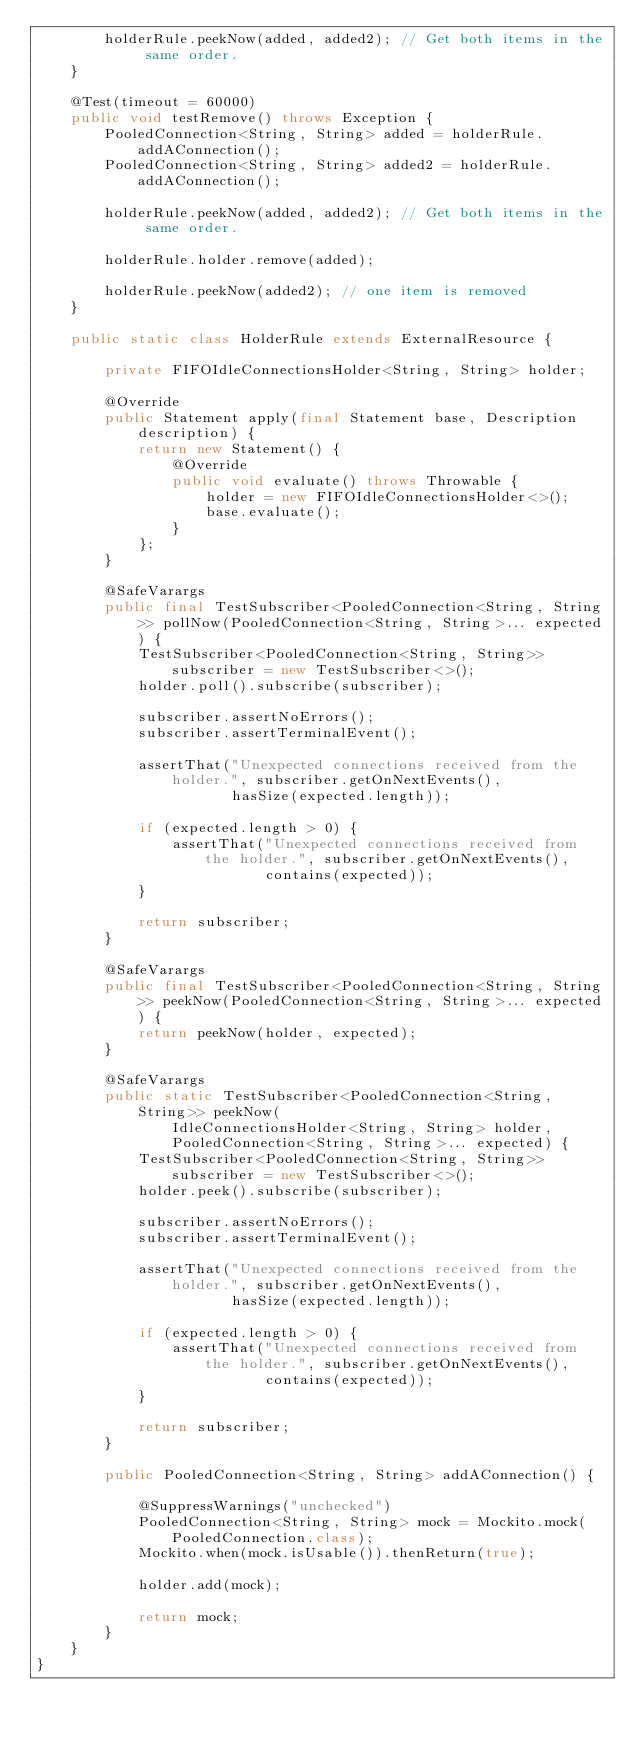<code> <loc_0><loc_0><loc_500><loc_500><_Java_>        holderRule.peekNow(added, added2); // Get both items in the same order.
    }

    @Test(timeout = 60000)
    public void testRemove() throws Exception {
        PooledConnection<String, String> added = holderRule.addAConnection();
        PooledConnection<String, String> added2 = holderRule.addAConnection();

        holderRule.peekNow(added, added2); // Get both items in the same order.

        holderRule.holder.remove(added);

        holderRule.peekNow(added2); // one item is removed
    }

    public static class HolderRule extends ExternalResource {

        private FIFOIdleConnectionsHolder<String, String> holder;

        @Override
        public Statement apply(final Statement base, Description description) {
            return new Statement() {
                @Override
                public void evaluate() throws Throwable {
                    holder = new FIFOIdleConnectionsHolder<>();
                    base.evaluate();
                }
            };
        }

        @SafeVarargs
        public final TestSubscriber<PooledConnection<String, String>> pollNow(PooledConnection<String, String>... expected) {
            TestSubscriber<PooledConnection<String, String>> subscriber = new TestSubscriber<>();
            holder.poll().subscribe(subscriber);

            subscriber.assertNoErrors();
            subscriber.assertTerminalEvent();

            assertThat("Unexpected connections received from the holder.", subscriber.getOnNextEvents(),
                       hasSize(expected.length));

            if (expected.length > 0) {
                assertThat("Unexpected connections received from the holder.", subscriber.getOnNextEvents(),
                           contains(expected));
            }

            return subscriber;
        }

        @SafeVarargs
        public final TestSubscriber<PooledConnection<String, String>> peekNow(PooledConnection<String, String>... expected) {
            return peekNow(holder, expected);
        }

        @SafeVarargs
        public static TestSubscriber<PooledConnection<String, String>> peekNow(
                IdleConnectionsHolder<String, String> holder,
                PooledConnection<String, String>... expected) {
            TestSubscriber<PooledConnection<String, String>> subscriber = new TestSubscriber<>();
            holder.peek().subscribe(subscriber);

            subscriber.assertNoErrors();
            subscriber.assertTerminalEvent();

            assertThat("Unexpected connections received from the holder.", subscriber.getOnNextEvents(),
                       hasSize(expected.length));

            if (expected.length > 0) {
                assertThat("Unexpected connections received from the holder.", subscriber.getOnNextEvents(),
                           contains(expected));
            }

            return subscriber;
        }

        public PooledConnection<String, String> addAConnection() {

            @SuppressWarnings("unchecked")
            PooledConnection<String, String> mock = Mockito.mock(PooledConnection.class);
            Mockito.when(mock.isUsable()).thenReturn(true);

            holder.add(mock);

            return mock;
        }
    }
}</code> 